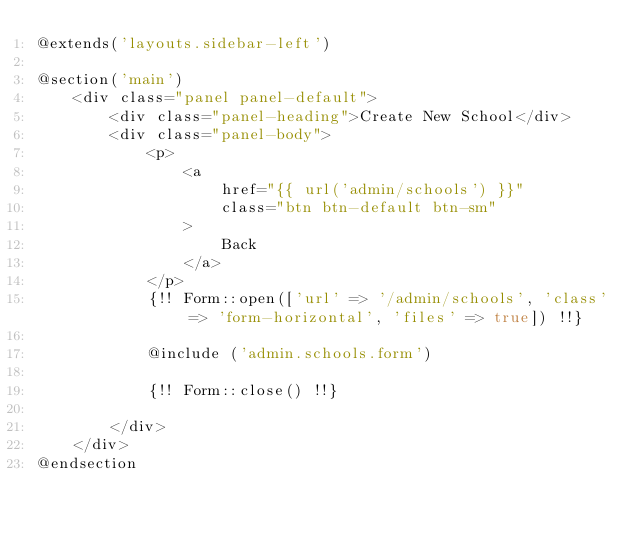<code> <loc_0><loc_0><loc_500><loc_500><_PHP_>@extends('layouts.sidebar-left')

@section('main')
    <div class="panel panel-default">
        <div class="panel-heading">Create New School</div>
        <div class="panel-body">
            <p>
                <a
                    href="{{ url('admin/schools') }}"
                    class="btn btn-default btn-sm"
                >
                    Back
                </a>
            </p>
            {!! Form::open(['url' => '/admin/schools', 'class' => 'form-horizontal', 'files' => true]) !!}

            @include ('admin.schools.form')

            {!! Form::close() !!}

        </div>
    </div>
@endsection</code> 